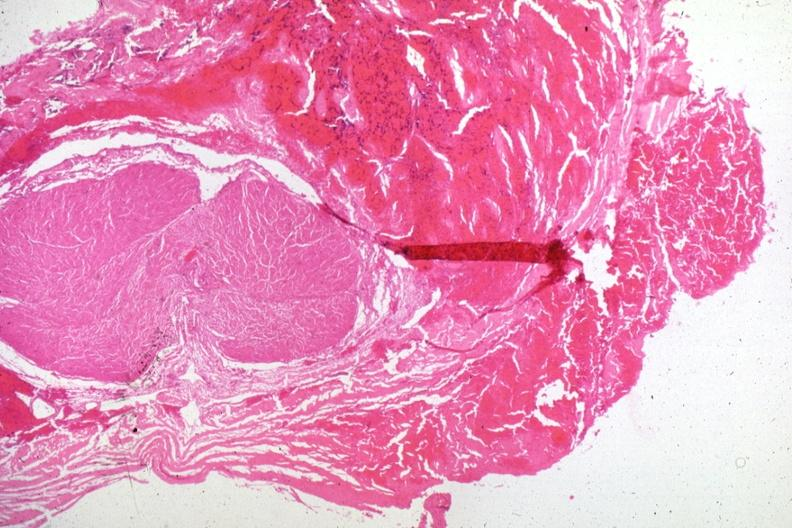s beckwith-wiedemann syndrome present?
Answer the question using a single word or phrase. No 